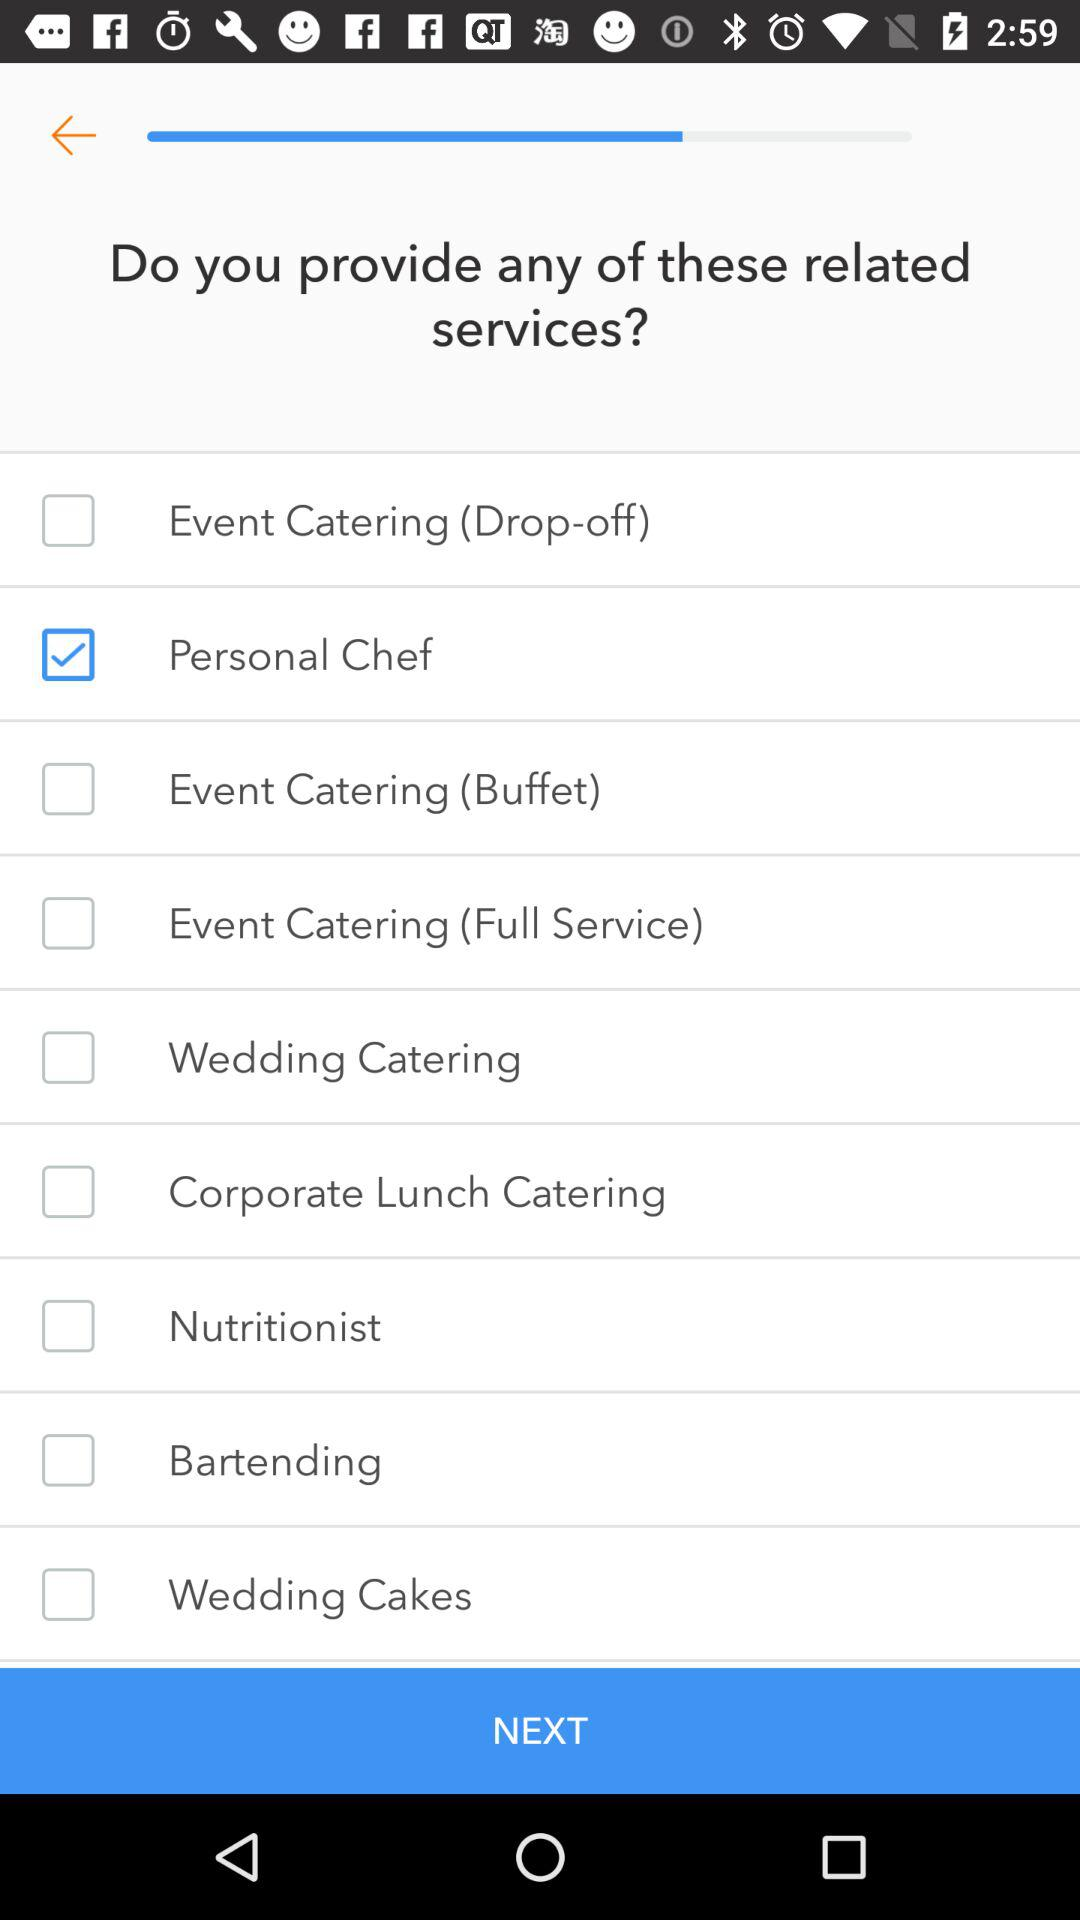How many services are available?
Answer the question using a single word or phrase. 9 